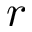<formula> <loc_0><loc_0><loc_500><loc_500>r</formula> 